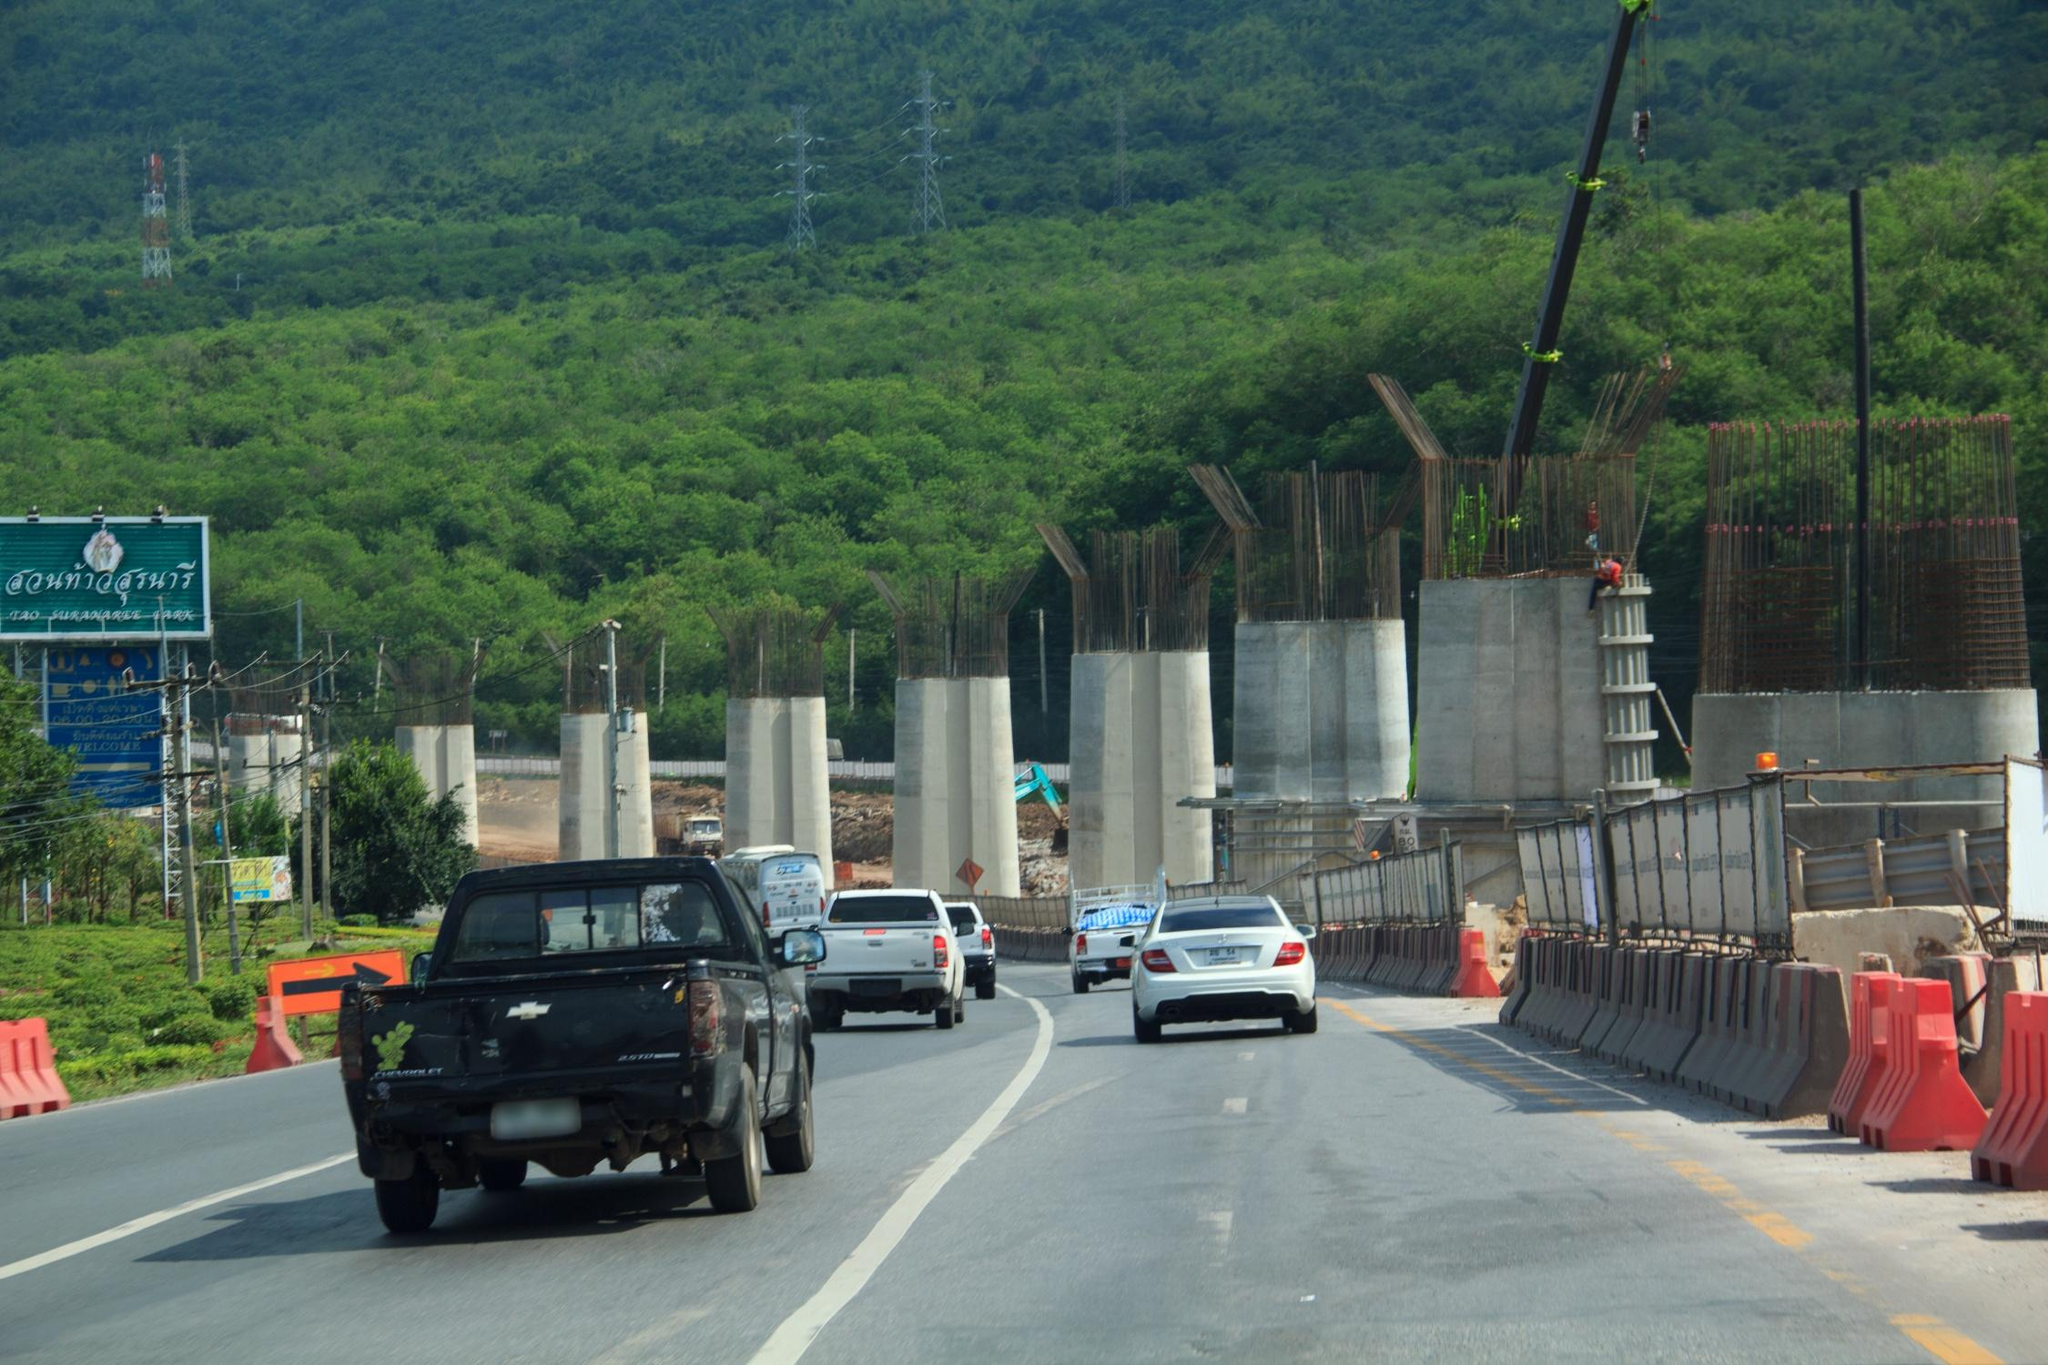What kinds of construction vehicles and cranes are visible in the image, and what are their purposes? In the image, several types of construction vehicles and cranes are visible, each serving distinct purposes. You can see excavators, which are used for digging and moving large amounts of earth. There are also bulldozers, designed for pushing large quantities of soil or rubble. Cranes, towering over the construction site, are essential for lifting and transporting heavy materials like steel beams and concrete sections to precise locations. Additionally, there might be cement mixers involved in preparing concrete for foundations and other structural elements. Each of these machines plays a critical role in ensuring the efficient and timely construction of the highway. 